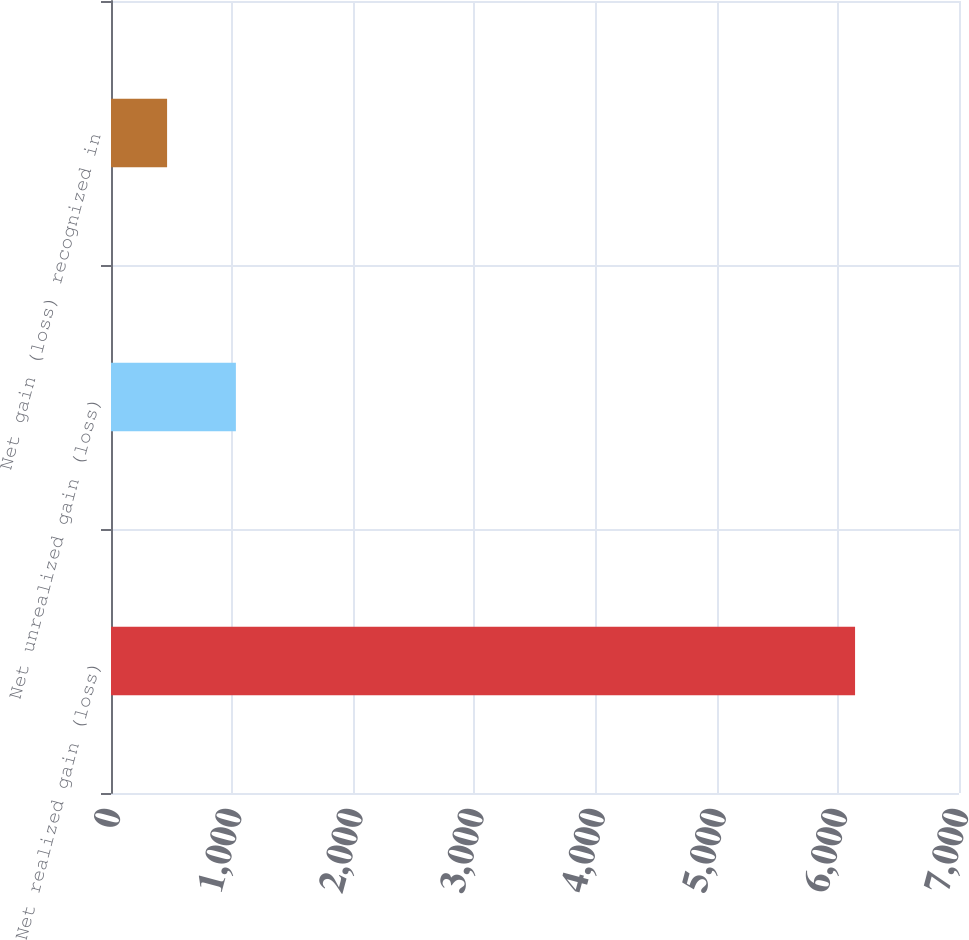<chart> <loc_0><loc_0><loc_500><loc_500><bar_chart><fcel>Net realized gain (loss)<fcel>Net unrealized gain (loss)<fcel>Net gain (loss) recognized in<nl><fcel>6142<fcel>1030.9<fcel>463<nl></chart> 